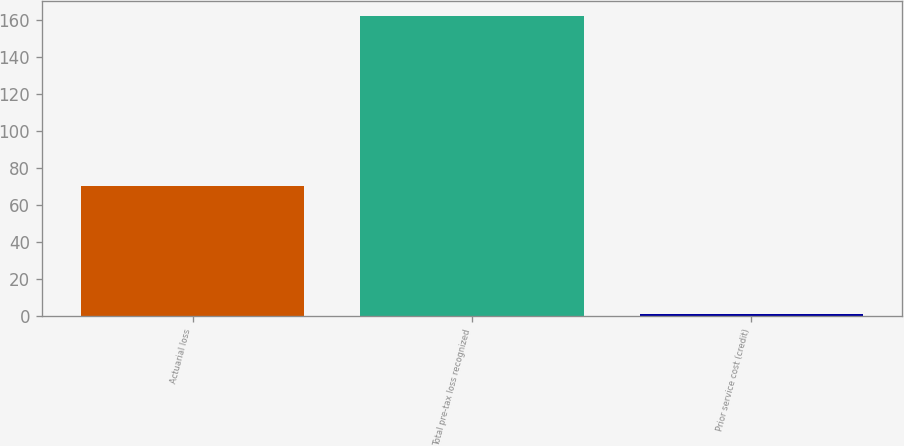Convert chart. <chart><loc_0><loc_0><loc_500><loc_500><bar_chart><fcel>Actuarial loss<fcel>Total pre-tax loss recognized<fcel>Prior service cost (credit)<nl><fcel>70.1<fcel>162<fcel>1<nl></chart> 